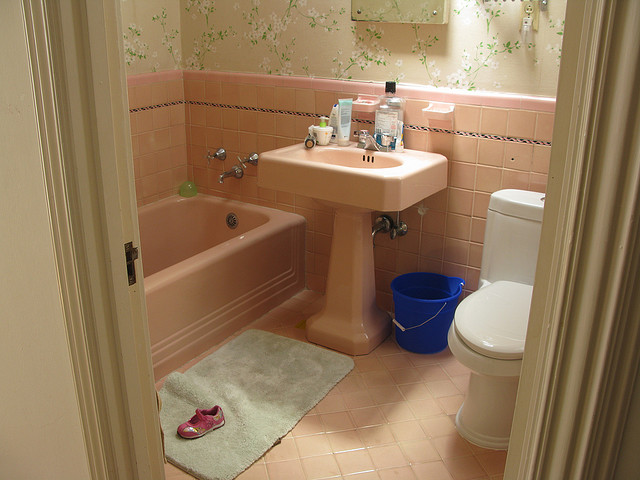<image>What color is the cup? I am not sure. The cup may be white or blue. What color is the cup? The cup in the image is white. 